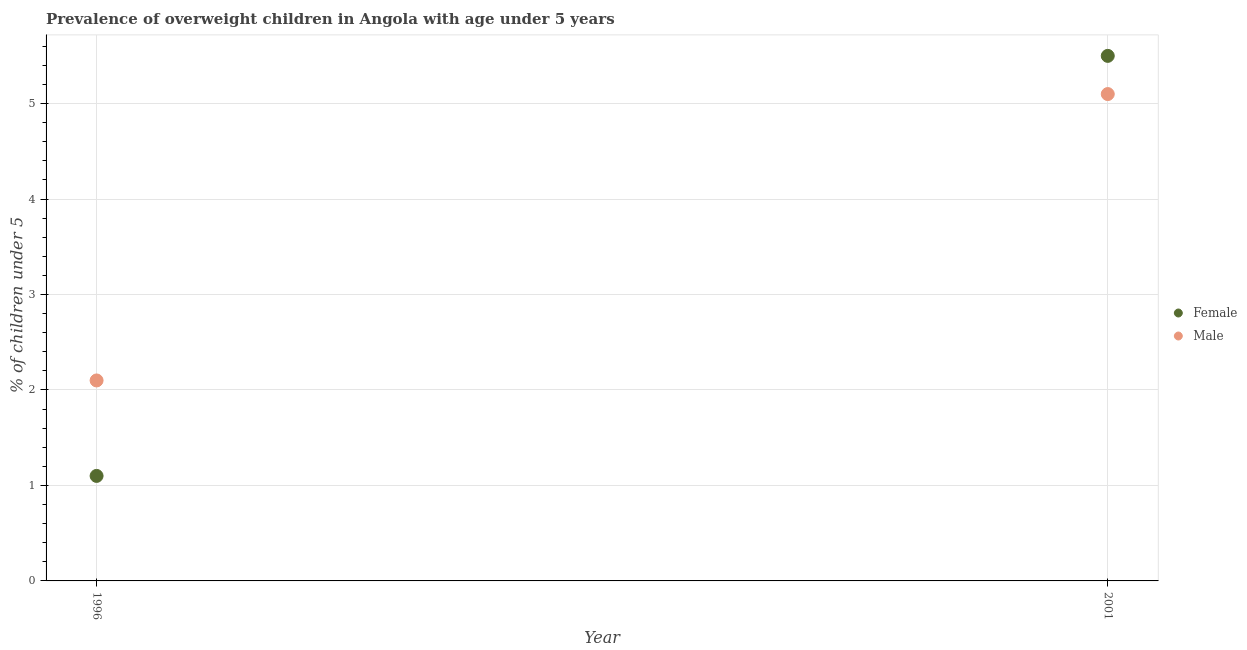How many different coloured dotlines are there?
Provide a succinct answer. 2. Is the number of dotlines equal to the number of legend labels?
Your answer should be compact. Yes. What is the percentage of obese male children in 2001?
Keep it short and to the point. 5.1. Across all years, what is the minimum percentage of obese female children?
Provide a short and direct response. 1.1. What is the total percentage of obese female children in the graph?
Your answer should be very brief. 6.6. What is the difference between the percentage of obese male children in 2001 and the percentage of obese female children in 1996?
Give a very brief answer. 4. What is the average percentage of obese female children per year?
Provide a short and direct response. 3.3. In the year 1996, what is the difference between the percentage of obese female children and percentage of obese male children?
Provide a succinct answer. -1. What is the ratio of the percentage of obese female children in 1996 to that in 2001?
Provide a short and direct response. 0.2. Is the percentage of obese female children in 1996 less than that in 2001?
Your response must be concise. Yes. In how many years, is the percentage of obese male children greater than the average percentage of obese male children taken over all years?
Ensure brevity in your answer.  1. Does the percentage of obese male children monotonically increase over the years?
Provide a short and direct response. Yes. How many years are there in the graph?
Offer a terse response. 2. What is the difference between two consecutive major ticks on the Y-axis?
Provide a short and direct response. 1. How many legend labels are there?
Keep it short and to the point. 2. How are the legend labels stacked?
Your answer should be very brief. Vertical. What is the title of the graph?
Give a very brief answer. Prevalence of overweight children in Angola with age under 5 years. Does "Investment in Transport" appear as one of the legend labels in the graph?
Ensure brevity in your answer.  No. What is the label or title of the X-axis?
Provide a succinct answer. Year. What is the label or title of the Y-axis?
Keep it short and to the point.  % of children under 5. What is the  % of children under 5 of Female in 1996?
Ensure brevity in your answer.  1.1. What is the  % of children under 5 of Male in 1996?
Your answer should be very brief. 2.1. What is the  % of children under 5 in Female in 2001?
Ensure brevity in your answer.  5.5. What is the  % of children under 5 of Male in 2001?
Your answer should be very brief. 5.1. Across all years, what is the maximum  % of children under 5 of Female?
Ensure brevity in your answer.  5.5. Across all years, what is the maximum  % of children under 5 in Male?
Your response must be concise. 5.1. Across all years, what is the minimum  % of children under 5 in Female?
Make the answer very short. 1.1. Across all years, what is the minimum  % of children under 5 in Male?
Keep it short and to the point. 2.1. What is the difference between the  % of children under 5 of Female in 1996 and that in 2001?
Keep it short and to the point. -4.4. What is the difference between the  % of children under 5 in Female in 1996 and the  % of children under 5 in Male in 2001?
Offer a very short reply. -4. In the year 2001, what is the difference between the  % of children under 5 of Female and  % of children under 5 of Male?
Your response must be concise. 0.4. What is the ratio of the  % of children under 5 in Male in 1996 to that in 2001?
Offer a terse response. 0.41. What is the difference between the highest and the second highest  % of children under 5 in Female?
Your answer should be compact. 4.4. What is the difference between the highest and the lowest  % of children under 5 in Female?
Your response must be concise. 4.4. What is the difference between the highest and the lowest  % of children under 5 of Male?
Ensure brevity in your answer.  3. 